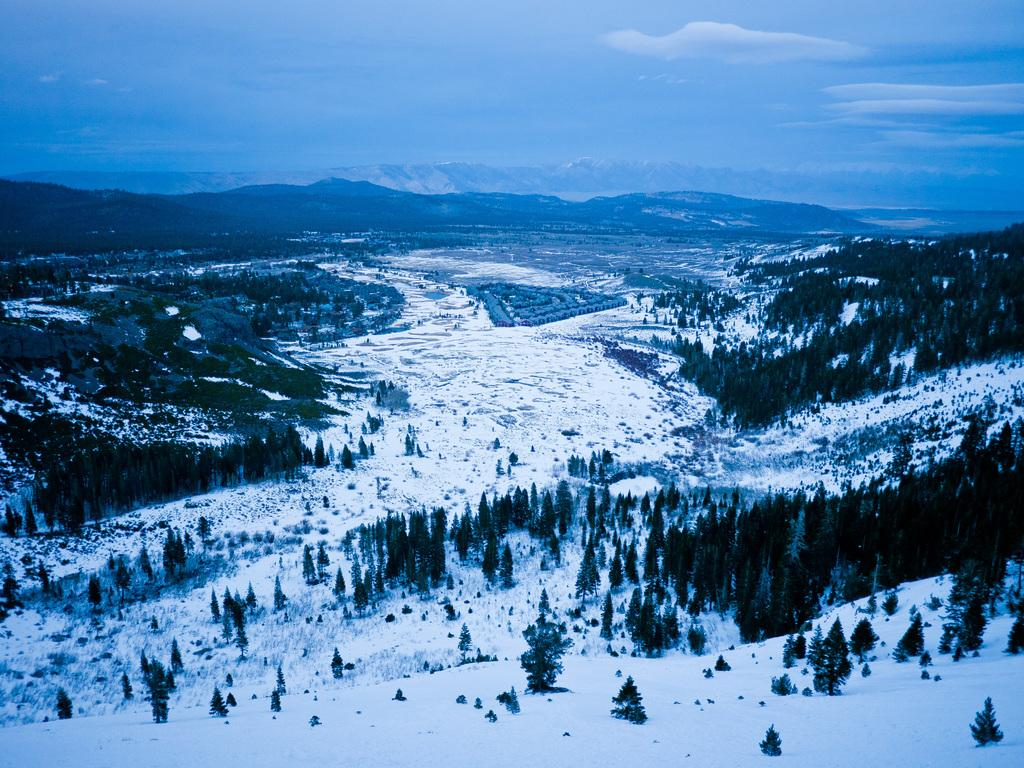What type of weather condition is depicted in the image? There is snow in the image. What natural elements can be seen in the image? There are trees and mountains in the image. What is visible in the background of the image? The sky is visible in the background of the image. Can you describe the person's experience while walking through the square in the image? There is no person or square present in the image; it features snow, trees, mountains, and the sky. 